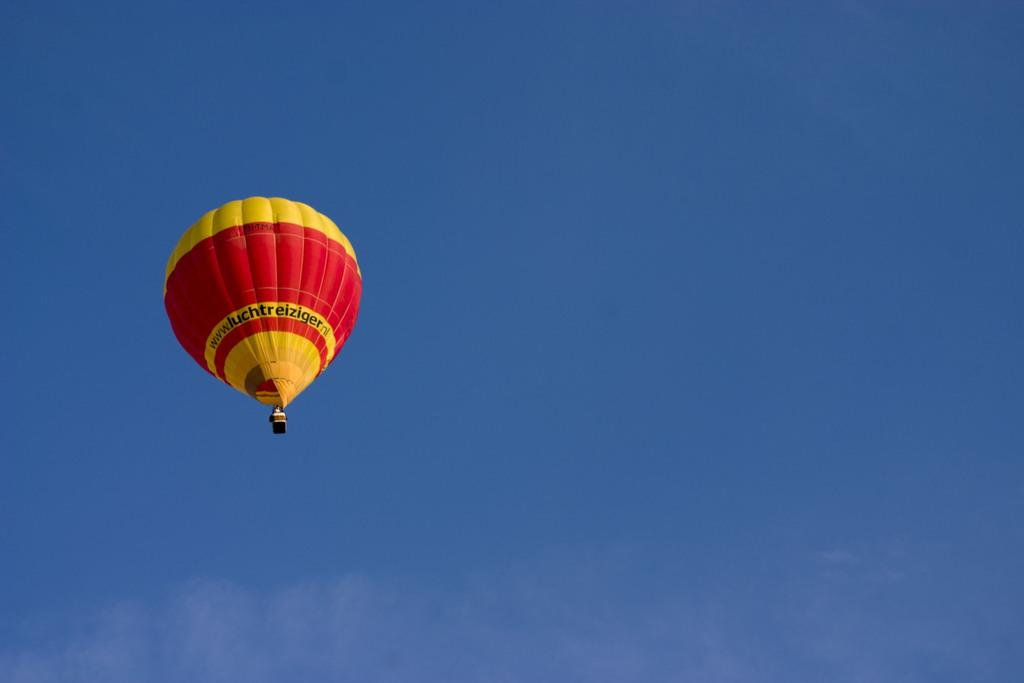What is visible in the sky in the image? There is a parachute in the sky in the image. What type of cannon is being used to launch pizzas in the image? There is no cannon or pizzas present in the image; it only features a parachute in the sky. 